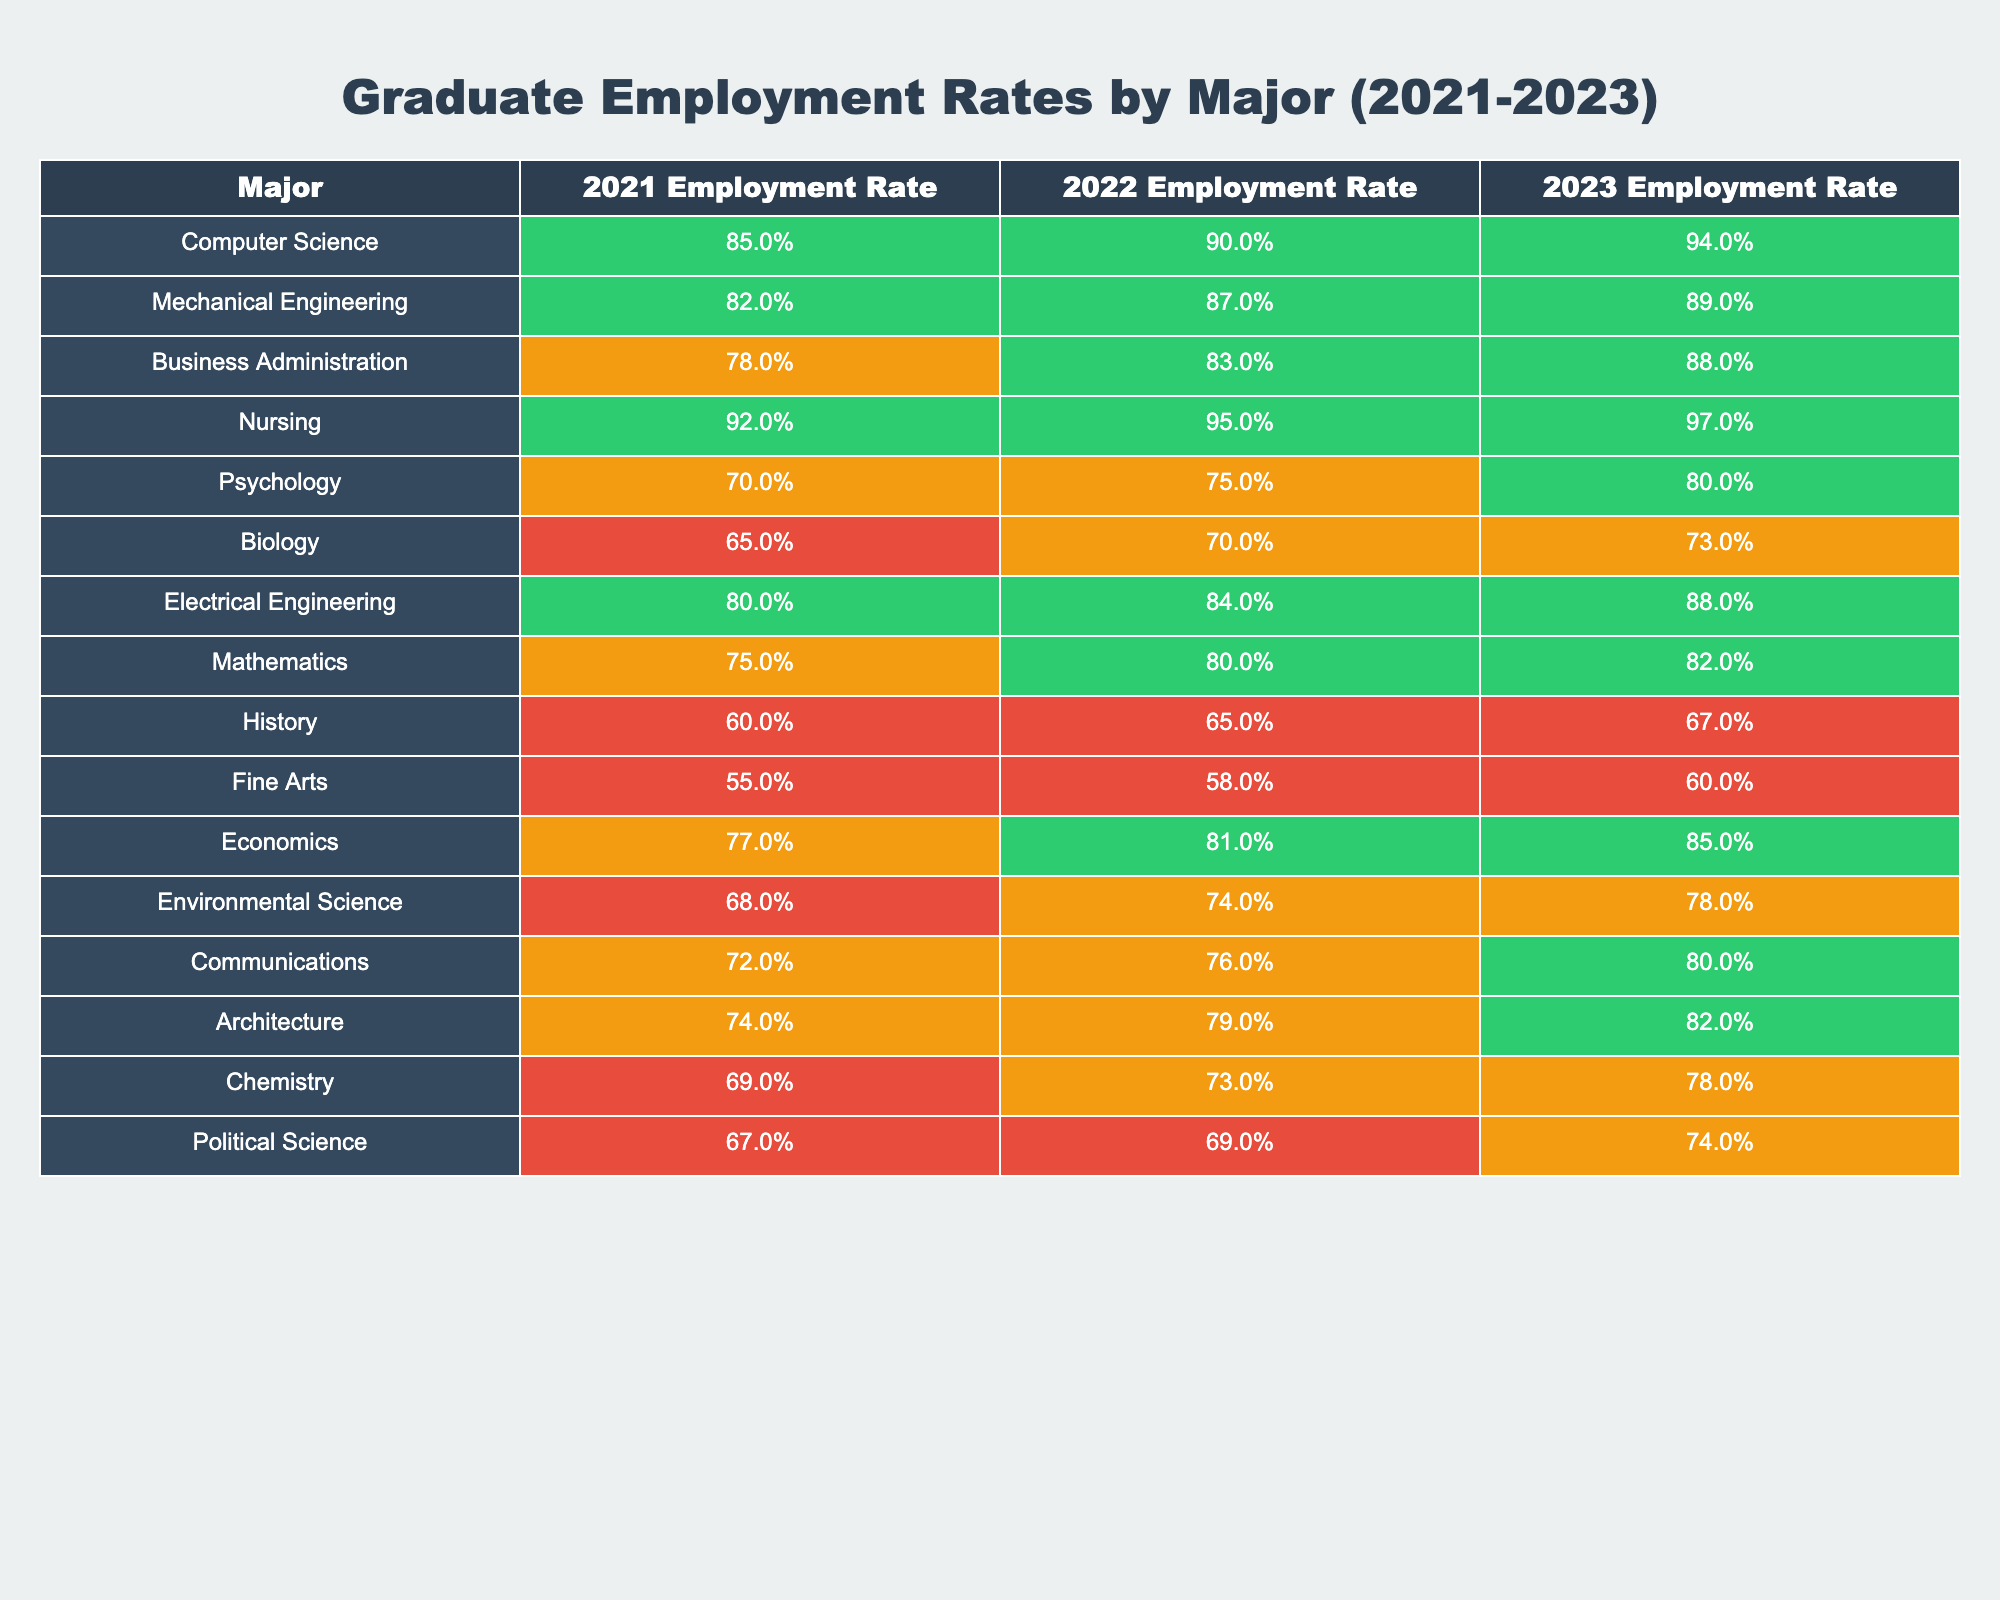What major had the highest employment rate in 2023? To find the highest employment rate in 2023, we look at all the percentages in the "2023 Employment Rate" column. The highest value is for Nursing at 97%.
Answer: Nursing Which major saw the biggest increase in employment rate from 2021 to 2023? To determine the biggest increase, we subtract the 2021 rate from the 2023 rate for each major. The increases are calculated as follows: Nursing (5%), Computer Science (9%), Mechanical Engineering (7%), etc. The largest increase is for Computer Science, which increased by 9%.
Answer: Computer Science Is the employment rate for Psychology higher than for Biology in 2022? We can compare the "2022 Employment Rate" for both Psychology (75%) and Biology (70%). Since 75% is greater than 70%, Psychology has a higher rate.
Answer: Yes What is the average employment rate for Business Administration over the three years? The average employment rate is calculated by adding the employment rates for Business Administration from 2021 (78%), 2022 (83%), and 2023 (88%), then dividing by 3. The sum is 249% and the average is 249/3 = 83%.
Answer: 83% Which major had the lowest employment rate in 2021 and how much lower was it compared to the highest? The lowest employment rate in 2021 is for Fine Arts at 55%. The highest for that year is Nursing at 92%. The difference is 92% - 55% = 37%.
Answer: 37% Did any major have an employment rate below 70% in 2023? We check the "2023 Employment Rate" column for any values below 70%. Psychology (80%), Biology (73%), Chemistry (78%), and Political Science (74%) are above this threshold, so none are below 70%.
Answer: No Which two majors have the closest employment rates in 2022? We look at the differences between the 2022 rates for all majors. The closest rates are for Electrical Engineering (84%) and Mechanical Engineering (87%), with a difference of 3%.
Answer: 3% What is the trend of employment rates for Environmental Science over the three years? Looking at the rates for Environmental Science: 68% in 2021, 74% in 2022, and 78% in 2023, we see an increasing trend year over year.
Answer: Increasing What is the total employment rate for all majors in 2021, and how does it compare to the total rate for 2023? We sum the employment rates for all majors in 2021 (Total = 1115%) and 2023 (Total = 1181%). Comparing them shows an increase of 66%.
Answer: 66% increase How many majors had employment rates over 80% in 2023? By reviewing the 2023 rates, we count the majors over 80%: Computer Science, Nursing, Electrical Engineering, Mathematics, Economics, Communications, Architecture, and Chemistry. That's 8 majors.
Answer: 8 